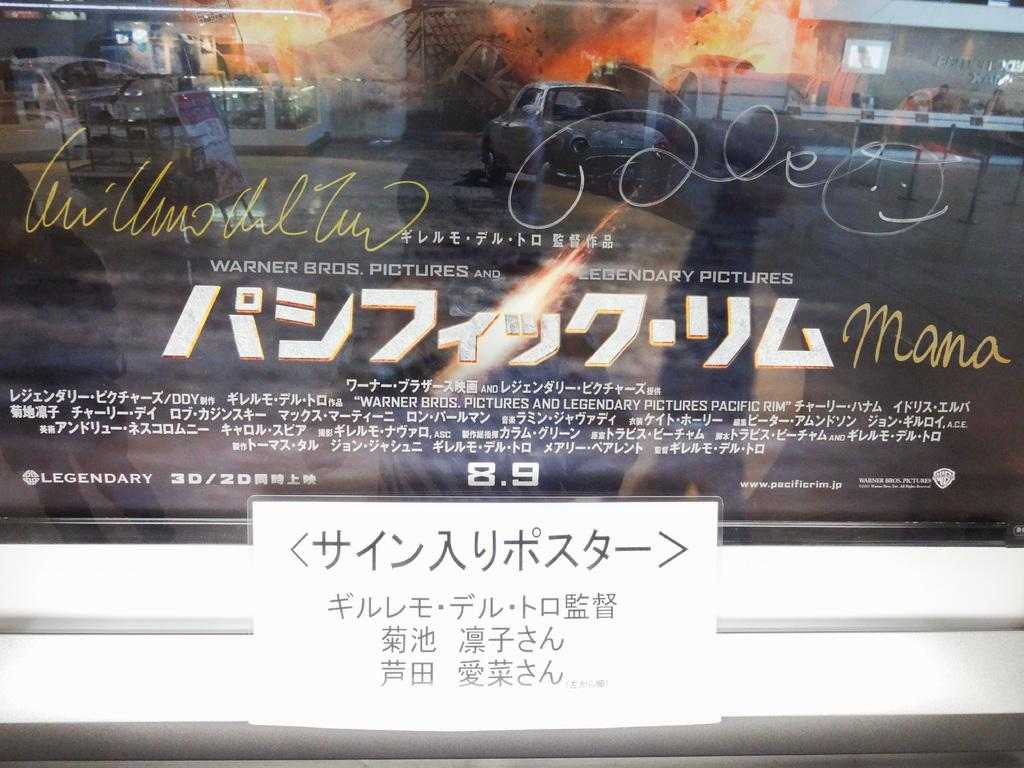<image>
Create a compact narrative representing the image presented. A Japanese movie poster is on display including the english words LEGENDARY and Mana. 